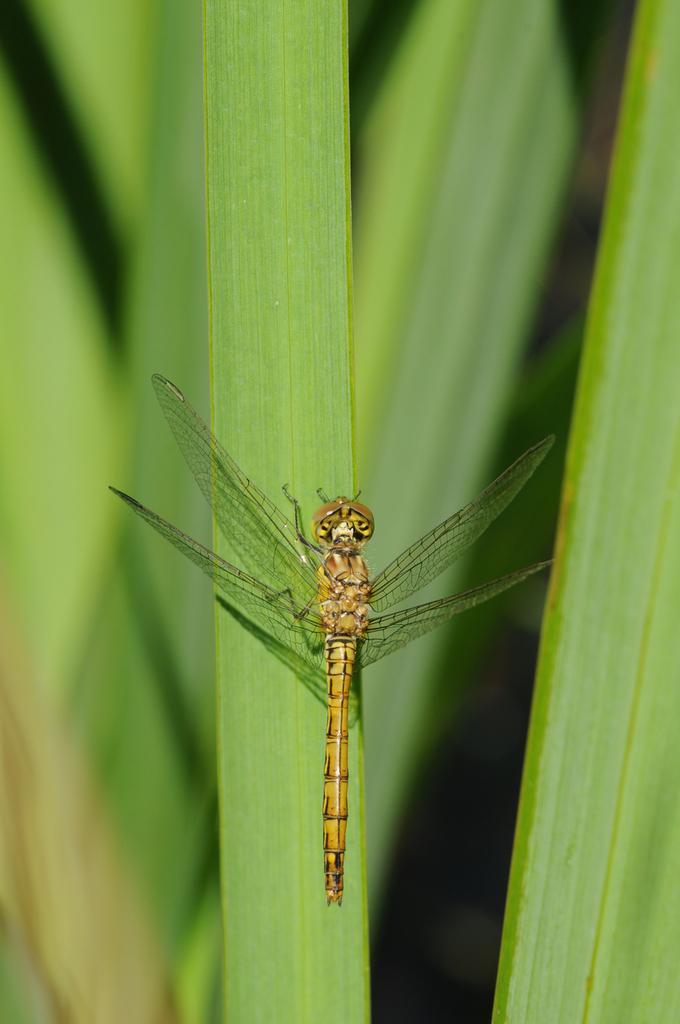Please provide a concise description of this image. In this image there is a fly on the green leaf. 